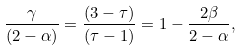Convert formula to latex. <formula><loc_0><loc_0><loc_500><loc_500>\frac { \gamma } { ( 2 - \alpha ) } = \frac { ( 3 - \tau ) } { ( \tau - 1 ) } = 1 - \frac { 2 \beta } { 2 - \alpha } ,</formula> 